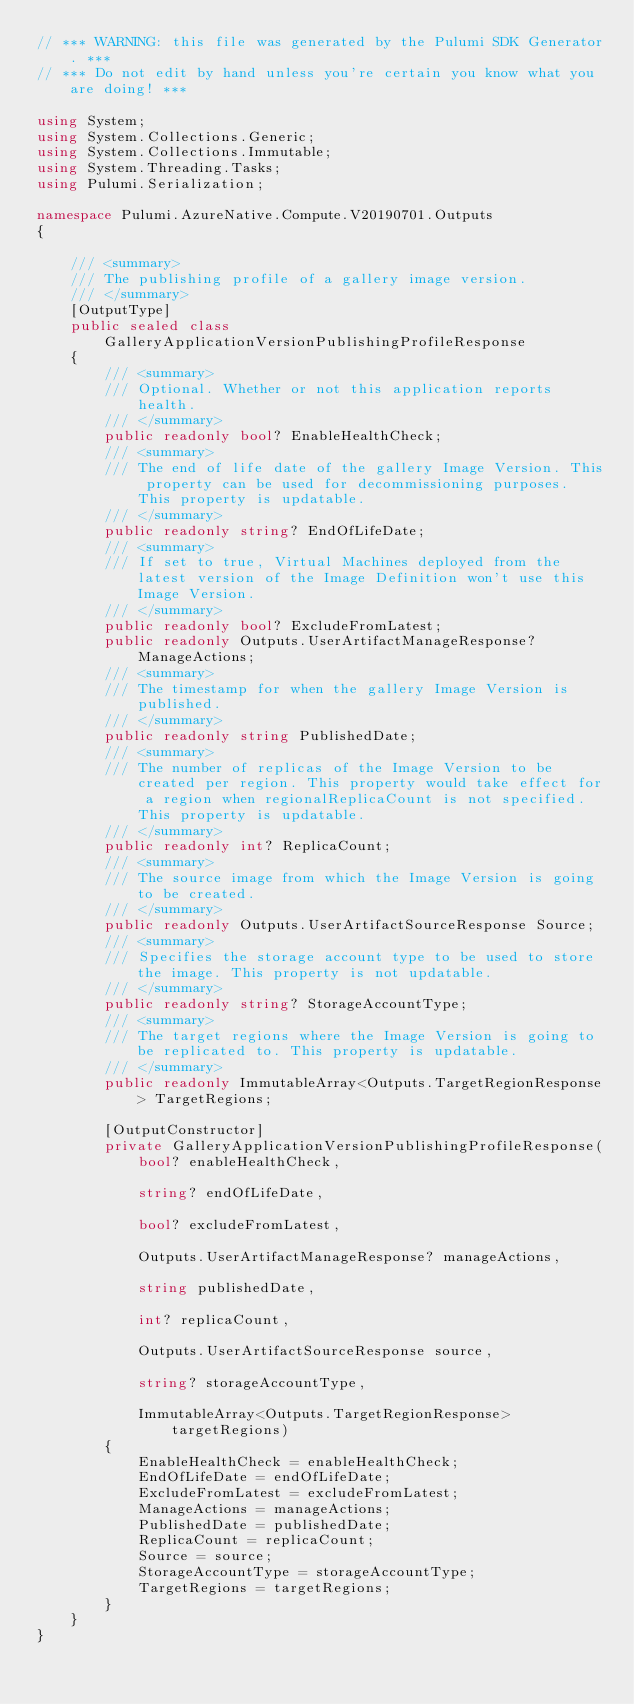<code> <loc_0><loc_0><loc_500><loc_500><_C#_>// *** WARNING: this file was generated by the Pulumi SDK Generator. ***
// *** Do not edit by hand unless you're certain you know what you are doing! ***

using System;
using System.Collections.Generic;
using System.Collections.Immutable;
using System.Threading.Tasks;
using Pulumi.Serialization;

namespace Pulumi.AzureNative.Compute.V20190701.Outputs
{

    /// <summary>
    /// The publishing profile of a gallery image version.
    /// </summary>
    [OutputType]
    public sealed class GalleryApplicationVersionPublishingProfileResponse
    {
        /// <summary>
        /// Optional. Whether or not this application reports health.
        /// </summary>
        public readonly bool? EnableHealthCheck;
        /// <summary>
        /// The end of life date of the gallery Image Version. This property can be used for decommissioning purposes. This property is updatable.
        /// </summary>
        public readonly string? EndOfLifeDate;
        /// <summary>
        /// If set to true, Virtual Machines deployed from the latest version of the Image Definition won't use this Image Version.
        /// </summary>
        public readonly bool? ExcludeFromLatest;
        public readonly Outputs.UserArtifactManageResponse? ManageActions;
        /// <summary>
        /// The timestamp for when the gallery Image Version is published.
        /// </summary>
        public readonly string PublishedDate;
        /// <summary>
        /// The number of replicas of the Image Version to be created per region. This property would take effect for a region when regionalReplicaCount is not specified. This property is updatable.
        /// </summary>
        public readonly int? ReplicaCount;
        /// <summary>
        /// The source image from which the Image Version is going to be created.
        /// </summary>
        public readonly Outputs.UserArtifactSourceResponse Source;
        /// <summary>
        /// Specifies the storage account type to be used to store the image. This property is not updatable.
        /// </summary>
        public readonly string? StorageAccountType;
        /// <summary>
        /// The target regions where the Image Version is going to be replicated to. This property is updatable.
        /// </summary>
        public readonly ImmutableArray<Outputs.TargetRegionResponse> TargetRegions;

        [OutputConstructor]
        private GalleryApplicationVersionPublishingProfileResponse(
            bool? enableHealthCheck,

            string? endOfLifeDate,

            bool? excludeFromLatest,

            Outputs.UserArtifactManageResponse? manageActions,

            string publishedDate,

            int? replicaCount,

            Outputs.UserArtifactSourceResponse source,

            string? storageAccountType,

            ImmutableArray<Outputs.TargetRegionResponse> targetRegions)
        {
            EnableHealthCheck = enableHealthCheck;
            EndOfLifeDate = endOfLifeDate;
            ExcludeFromLatest = excludeFromLatest;
            ManageActions = manageActions;
            PublishedDate = publishedDate;
            ReplicaCount = replicaCount;
            Source = source;
            StorageAccountType = storageAccountType;
            TargetRegions = targetRegions;
        }
    }
}
</code> 